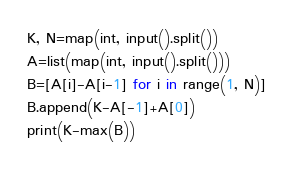<code> <loc_0><loc_0><loc_500><loc_500><_Python_>K, N=map(int, input().split())
A=list(map(int, input().split()))
B=[A[i]-A[i-1] for i in range(1, N)]
B.append(K-A[-1]+A[0])
print(K-max(B))</code> 